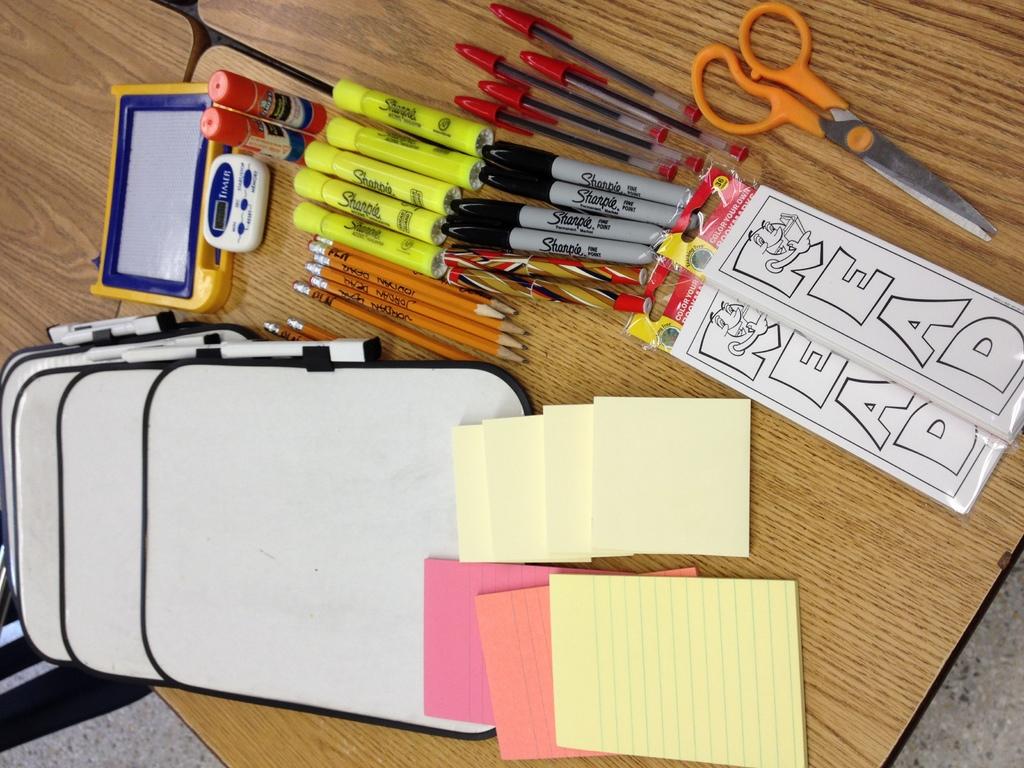What brand of marker are the black ones?
Ensure brevity in your answer.  Sharpie. What do the two black and white bookmarks say?
Provide a short and direct response. Read. 